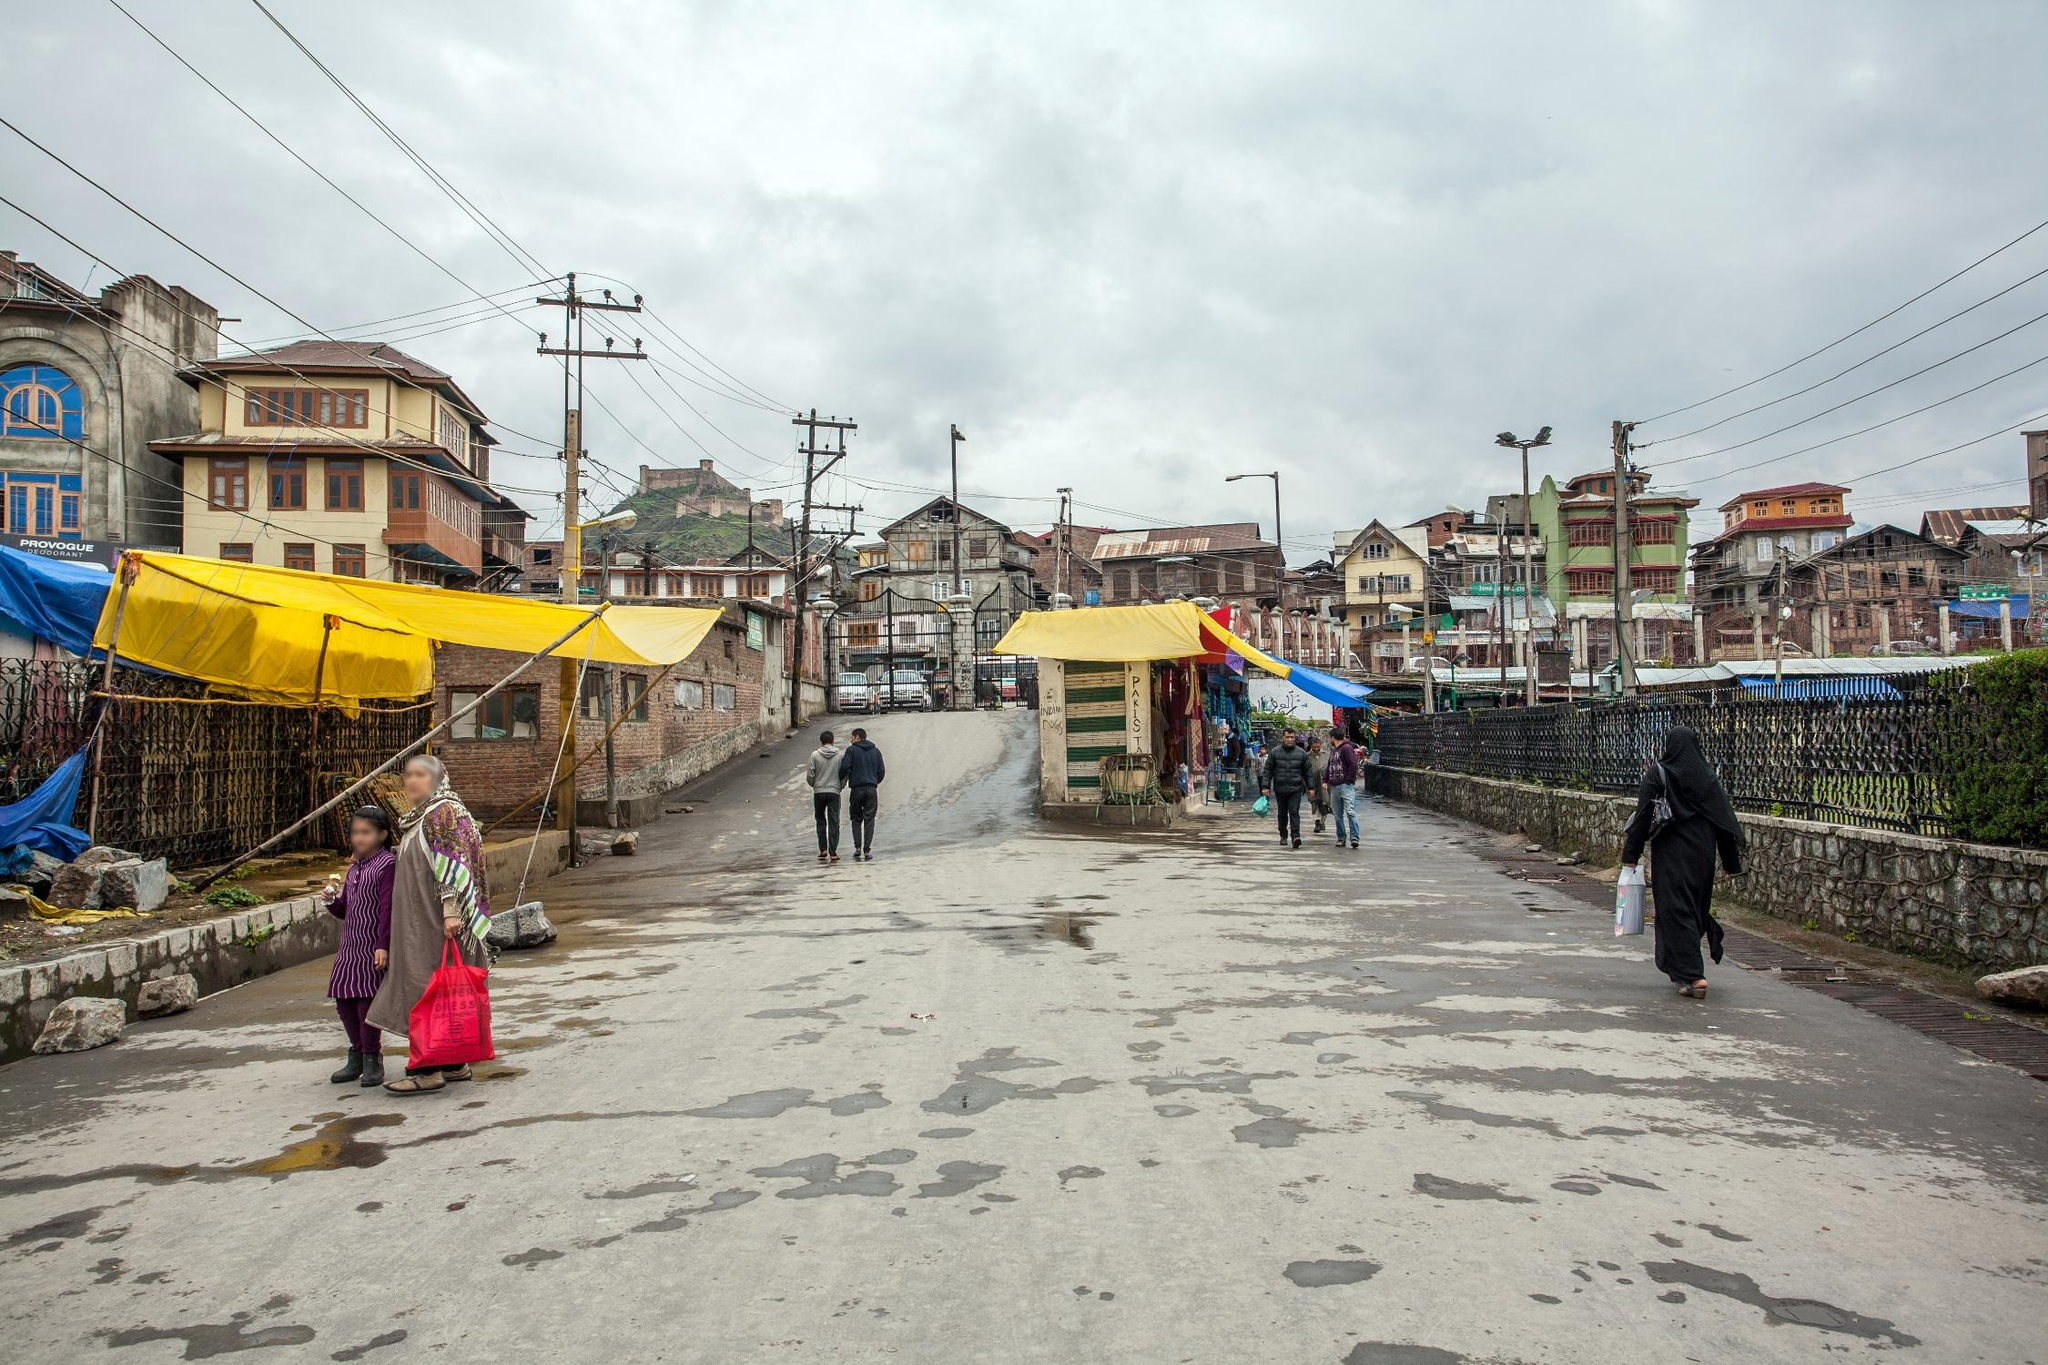Imagine that the image is part of a scene from a movie. What genre would the movie belong to and what might be happening in the plot? This image could easily be part of a dramatic or romantic movie. The overcast sky and bustling, colorful street provide a perfect setting for a narrative that explores themes of love, resilience, and everyday life's challenges. In the plot, these streets could witness a heartfelt reunion between long-lost lovers, or perhaps be the grounds for a struggle against an impending disaster, highlighting the indomitable spirit of the locals. What kind of conversation might people be having on this street? People on this street might be discussing anything from daily chores, market prices, and weather forecasts to sharing local gossip or stories of personal triumph. Vendors might be negotiating prices with customers, children may be pleading for a treat, and friends could catch up on events of the day while navigating the wet surfaces left by the rain. 